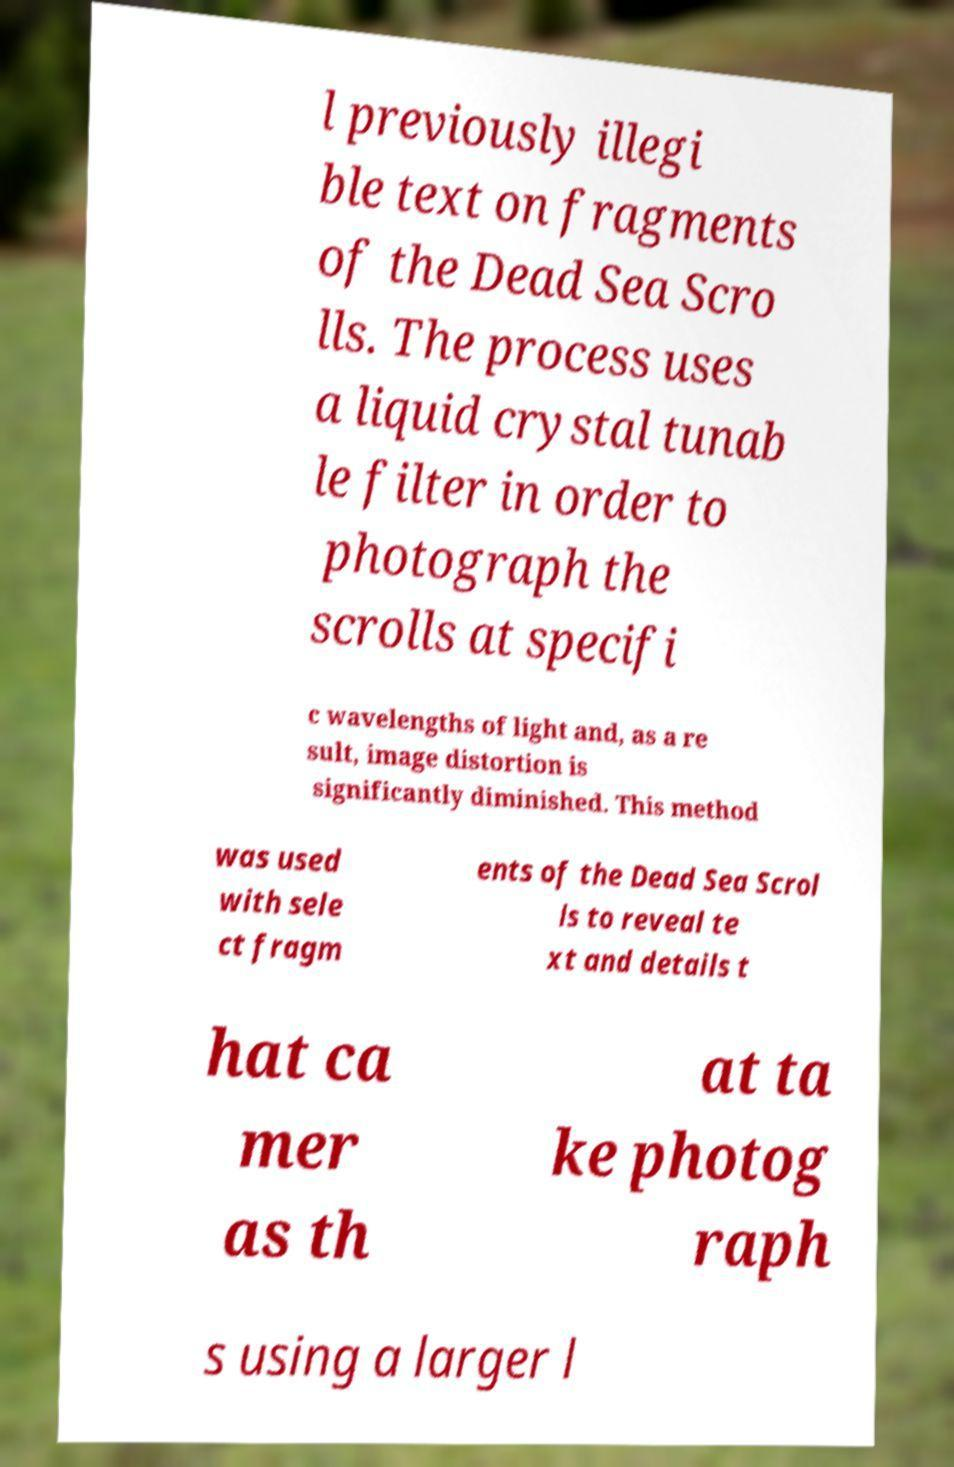Could you assist in decoding the text presented in this image and type it out clearly? l previously illegi ble text on fragments of the Dead Sea Scro lls. The process uses a liquid crystal tunab le filter in order to photograph the scrolls at specifi c wavelengths of light and, as a re sult, image distortion is significantly diminished. This method was used with sele ct fragm ents of the Dead Sea Scrol ls to reveal te xt and details t hat ca mer as th at ta ke photog raph s using a larger l 